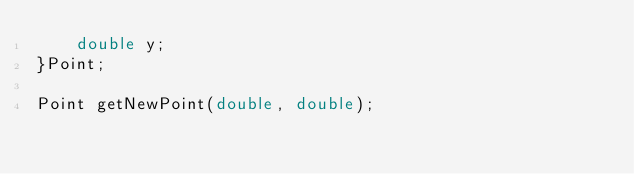Convert code to text. <code><loc_0><loc_0><loc_500><loc_500><_C_>    double y;
}Point;

Point getNewPoint(double, double);
</code> 